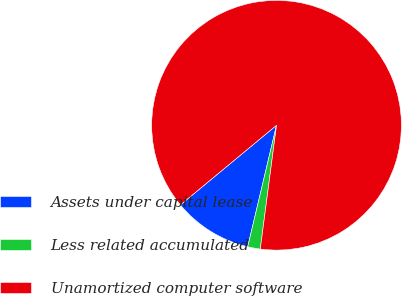Convert chart to OTSL. <chart><loc_0><loc_0><loc_500><loc_500><pie_chart><fcel>Assets under capital lease<fcel>Less related accumulated<fcel>Unamortized computer software<nl><fcel>10.28%<fcel>1.63%<fcel>88.09%<nl></chart> 